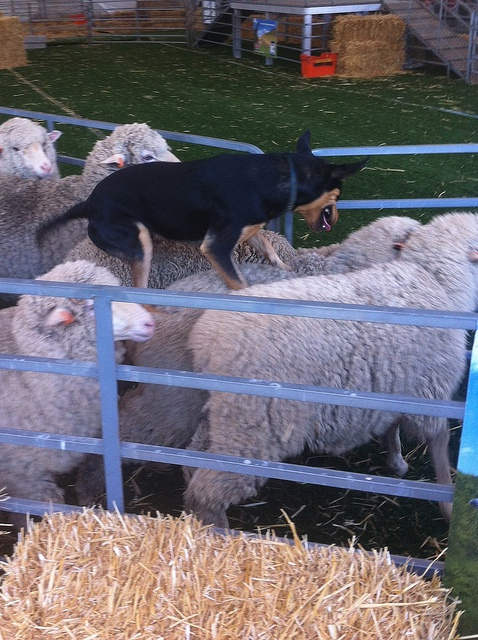Describe the objects in this image and their specific colors. I can see sheep in gray and darkgray tones, sheep in gray and darkgray tones, dog in gray, black, and darkgray tones, sheep in gray and darkgray tones, and sheep in gray, darkgray, and lavender tones in this image. 